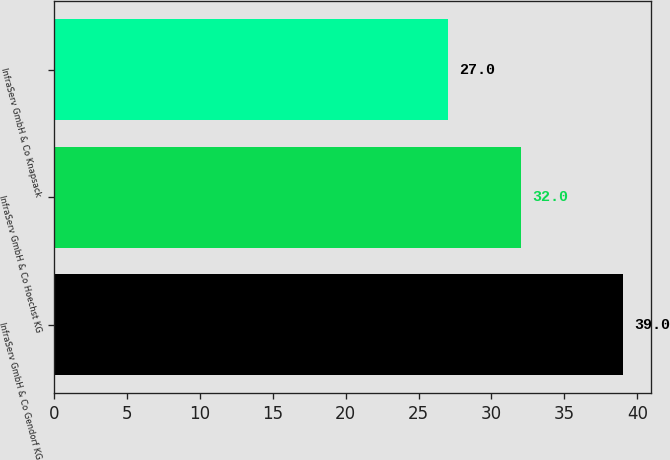<chart> <loc_0><loc_0><loc_500><loc_500><bar_chart><fcel>InfraServ GmbH & Co Gendorf KG<fcel>InfraServ GmbH & Co Hoechst KG<fcel>InfraServ GmbH & Co Knapsack<nl><fcel>39<fcel>32<fcel>27<nl></chart> 